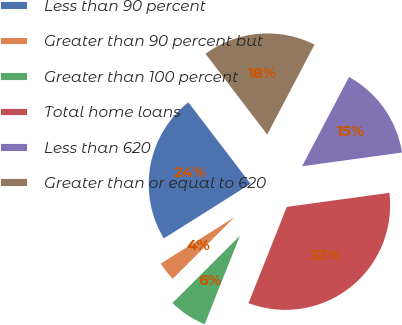Convert chart. <chart><loc_0><loc_0><loc_500><loc_500><pie_chart><fcel>Less than 90 percent<fcel>Greater than 90 percent but<fcel>Greater than 100 percent<fcel>Total home loans<fcel>Less than 620<fcel>Greater than or equal to 620<nl><fcel>23.56%<fcel>3.53%<fcel>6.5%<fcel>33.2%<fcel>15.12%<fcel>18.09%<nl></chart> 